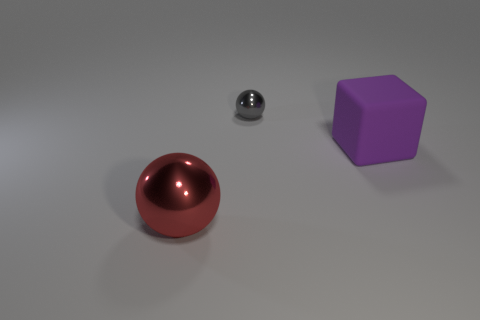How many big things are either blocks or objects? In the image, there are two large objects: one is a sizeable purple block, and the other is a prominent red sphere. These are the two big things that fit the criteria of being either blocks or objects. 